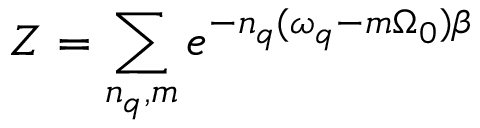Convert formula to latex. <formula><loc_0><loc_0><loc_500><loc_500>Z = \sum _ { n _ { q } , m } e ^ { - n _ { q } ( \omega _ { q } - m \Omega _ { 0 } ) \beta }</formula> 